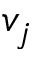Convert formula to latex. <formula><loc_0><loc_0><loc_500><loc_500>v _ { j }</formula> 